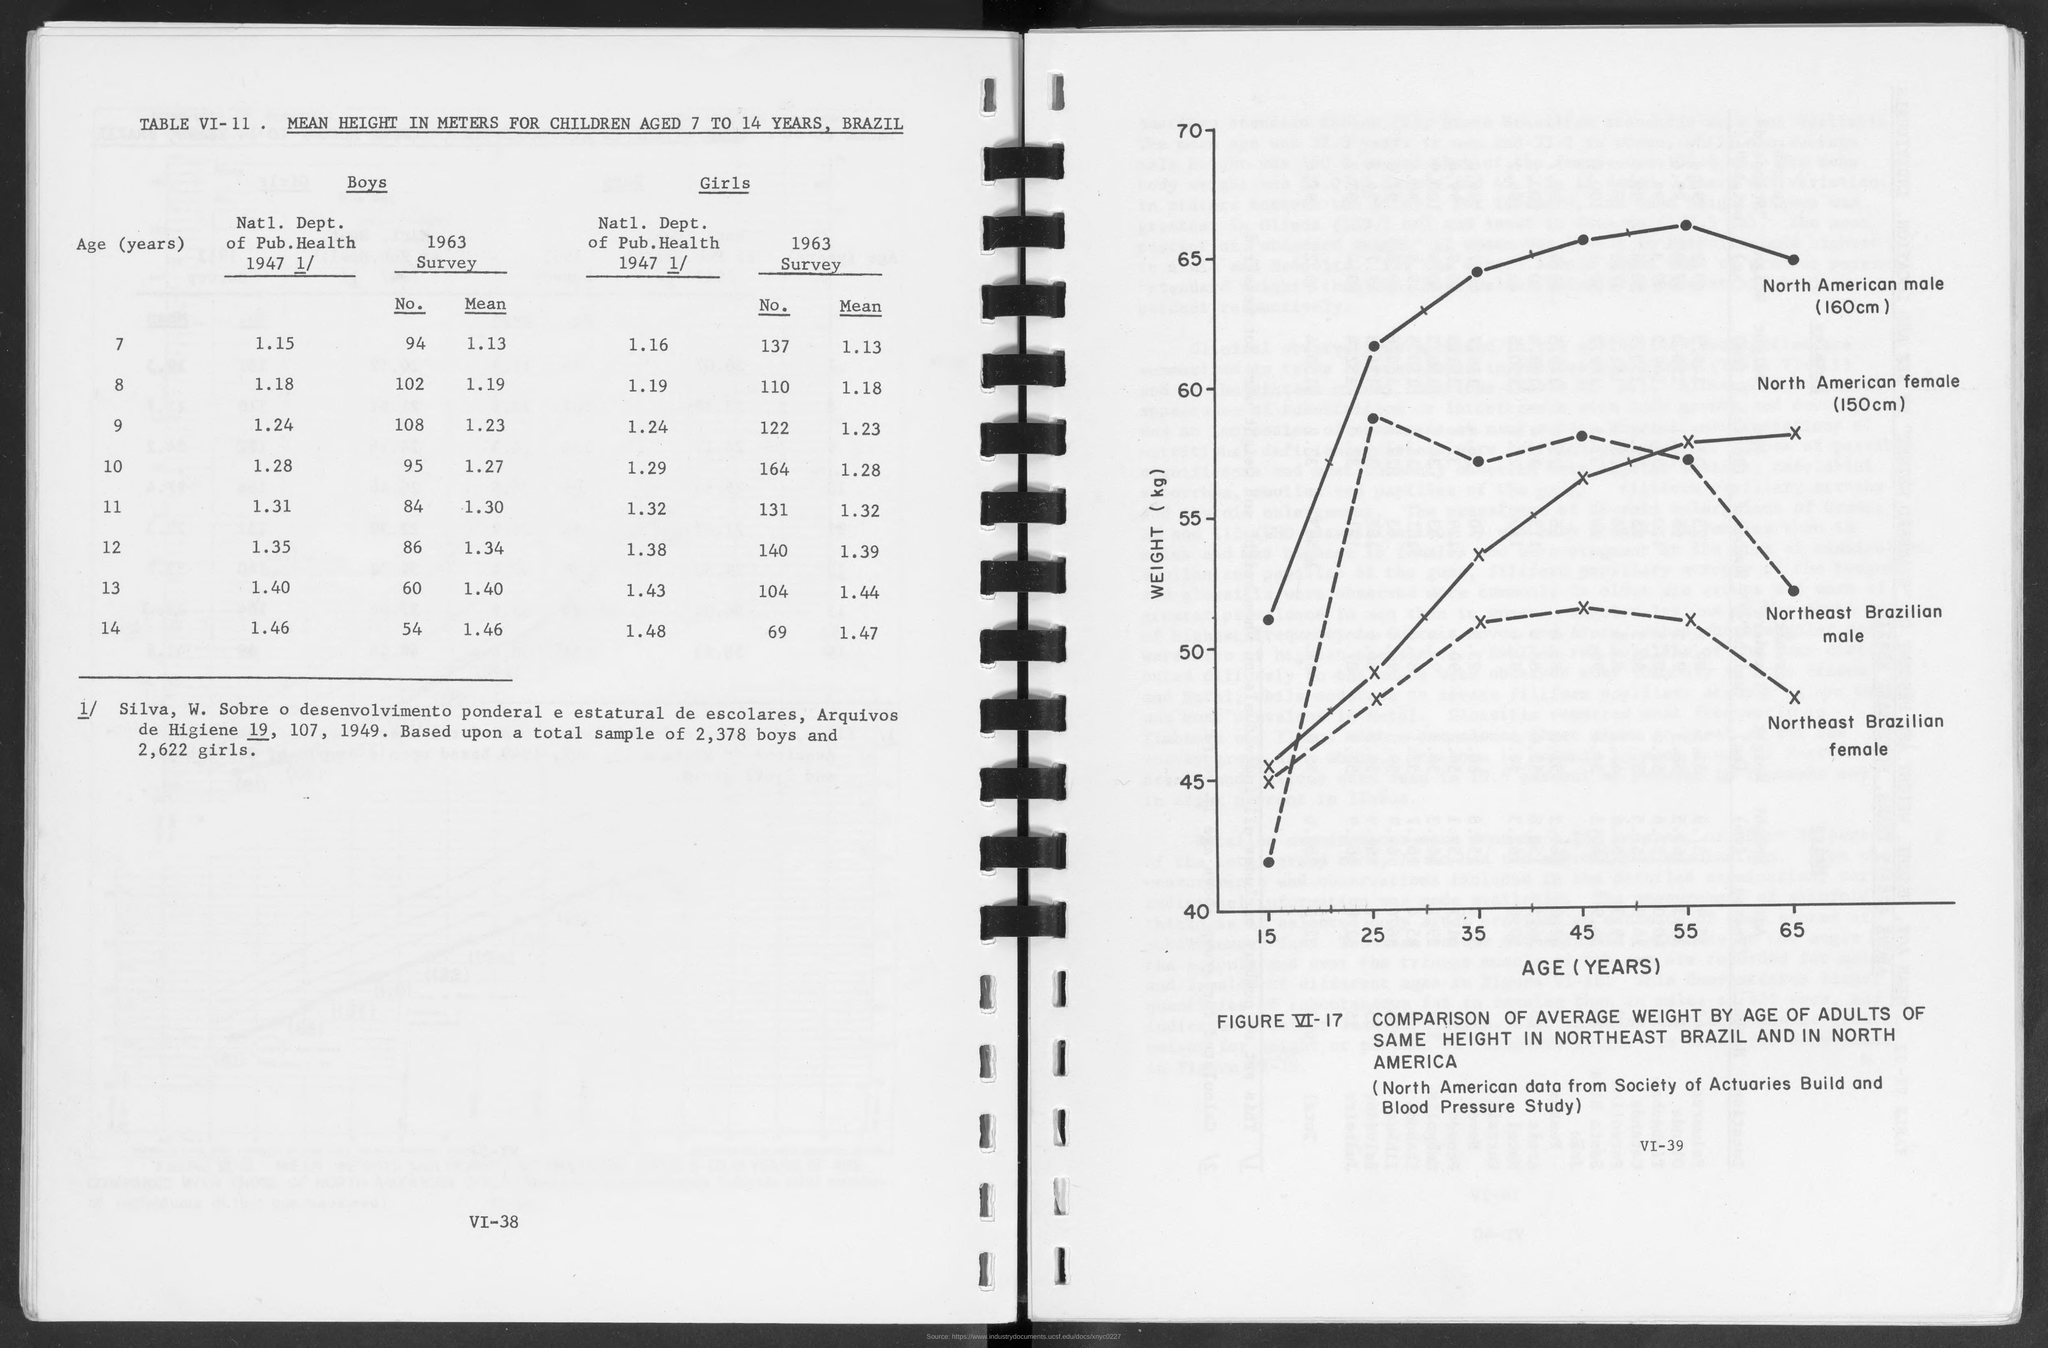List a handful of essential elements in this visual. The North American data used in the Society of Actuaries Blood Pressure Study was obtained from a reliable source. The variable on the y-axis of the graph in FIGURE VI-17 is weight (kg). The title of table VI-11 is "Mean Height in meters for Children aged 7 to 14 years, Brazil. The sample consisted of 2,378 individuals, with no distinction made based on gender. The variable on the X axis of the graph in FIGURE VI-17 is age. 